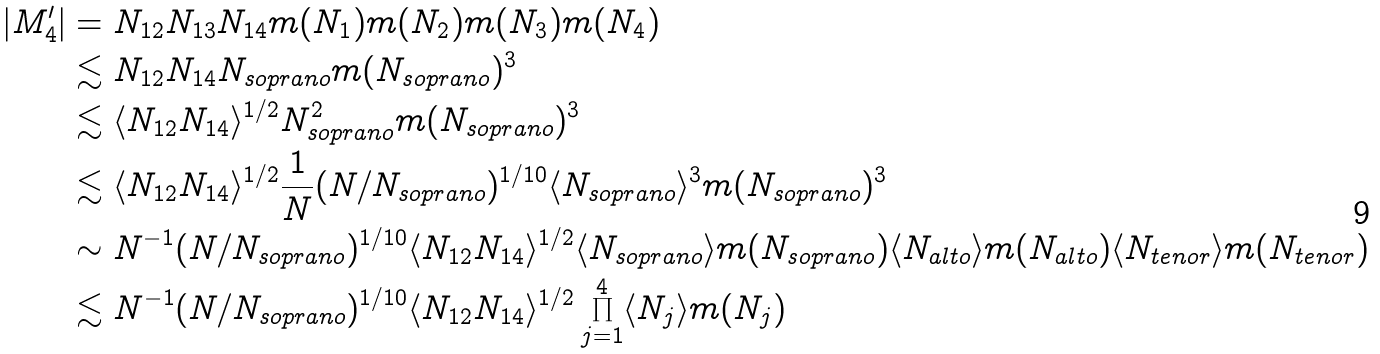Convert formula to latex. <formula><loc_0><loc_0><loc_500><loc_500>| M ^ { \prime } _ { 4 } | & = N _ { 1 2 } N _ { 1 3 } N _ { 1 4 } m ( N _ { 1 } ) m ( N _ { 2 } ) m ( N _ { 3 } ) m ( N _ { 4 } ) \\ & \lesssim N _ { 1 2 } N _ { 1 4 } N _ { s o p r a n o } m ( N _ { s o p r a n o } ) ^ { 3 } \\ & \lesssim \langle N _ { 1 2 } N _ { 1 4 } \rangle ^ { 1 / 2 } N _ { s o p r a n o } ^ { 2 } m ( N _ { s o p r a n o } ) ^ { 3 } \\ & \lesssim \langle N _ { 1 2 } N _ { 1 4 } \rangle ^ { 1 / 2 } \frac { 1 } { N } ( N / N _ { s o p r a n o } ) ^ { 1 / 1 0 } \langle N _ { s o p r a n o } \rangle ^ { 3 } m ( N _ { s o p r a n o } ) ^ { 3 } \\ & \sim N ^ { - 1 } ( N / N _ { s o p r a n o } ) ^ { 1 / 1 0 } \langle N _ { 1 2 } N _ { 1 4 } \rangle ^ { 1 / 2 } \langle N _ { s o p r a n o } \rangle m ( N _ { s o p r a n o } ) \langle N _ { a l t o } \rangle m ( N _ { a l t o } ) \langle N _ { t e n o r } \rangle m ( N _ { t e n o r } ) \\ & \lesssim N ^ { - 1 } ( N / N _ { s o p r a n o } ) ^ { 1 / 1 0 } \langle N _ { 1 2 } N _ { 1 4 } \rangle ^ { 1 / 2 } \prod _ { j = 1 } ^ { 4 } \langle N _ { j } \rangle m ( N _ { j } )</formula> 